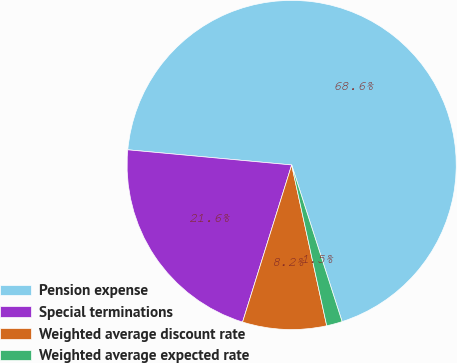Convert chart to OTSL. <chart><loc_0><loc_0><loc_500><loc_500><pie_chart><fcel>Pension expense<fcel>Special terminations<fcel>Weighted average discount rate<fcel>Weighted average expected rate<nl><fcel>68.58%<fcel>21.65%<fcel>8.24%<fcel>1.54%<nl></chart> 